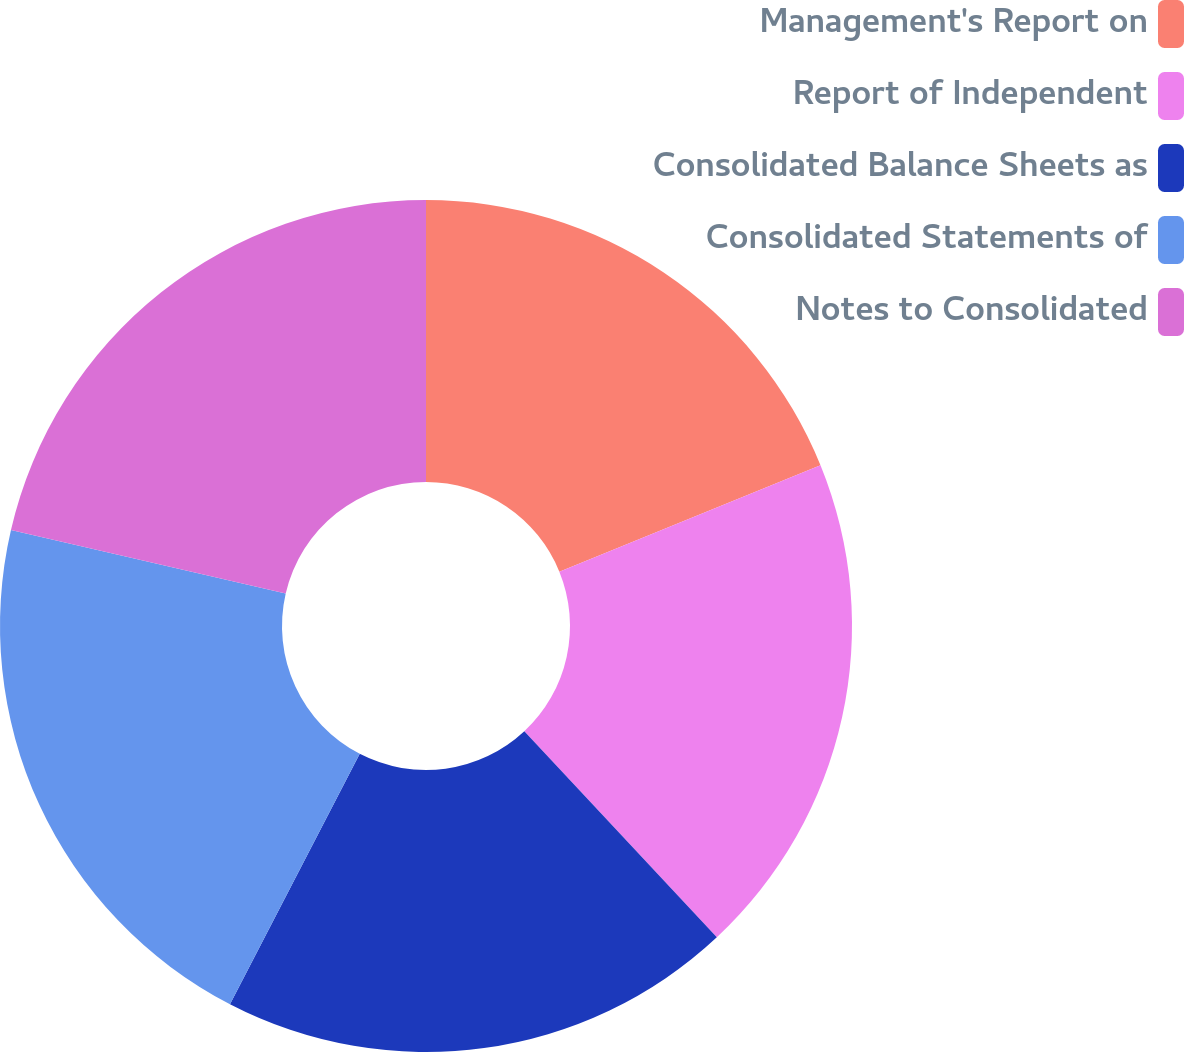<chart> <loc_0><loc_0><loc_500><loc_500><pie_chart><fcel>Management's Report on<fcel>Report of Independent<fcel>Consolidated Balance Sheets as<fcel>Consolidated Statements of<fcel>Notes to Consolidated<nl><fcel>18.84%<fcel>19.2%<fcel>19.57%<fcel>21.01%<fcel>21.38%<nl></chart> 